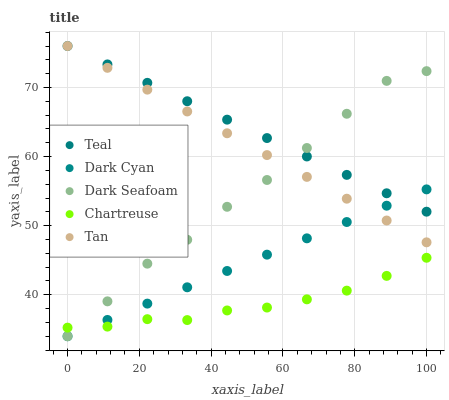Does Chartreuse have the minimum area under the curve?
Answer yes or no. Yes. Does Teal have the maximum area under the curve?
Answer yes or no. Yes. Does Dark Seafoam have the minimum area under the curve?
Answer yes or no. No. Does Dark Seafoam have the maximum area under the curve?
Answer yes or no. No. Is Dark Cyan the smoothest?
Answer yes or no. Yes. Is Dark Seafoam the roughest?
Answer yes or no. Yes. Is Tan the smoothest?
Answer yes or no. No. Is Tan the roughest?
Answer yes or no. No. Does Dark Cyan have the lowest value?
Answer yes or no. Yes. Does Tan have the lowest value?
Answer yes or no. No. Does Teal have the highest value?
Answer yes or no. Yes. Does Dark Seafoam have the highest value?
Answer yes or no. No. Is Chartreuse less than Teal?
Answer yes or no. Yes. Is Teal greater than Chartreuse?
Answer yes or no. Yes. Does Chartreuse intersect Dark Cyan?
Answer yes or no. Yes. Is Chartreuse less than Dark Cyan?
Answer yes or no. No. Is Chartreuse greater than Dark Cyan?
Answer yes or no. No. Does Chartreuse intersect Teal?
Answer yes or no. No. 